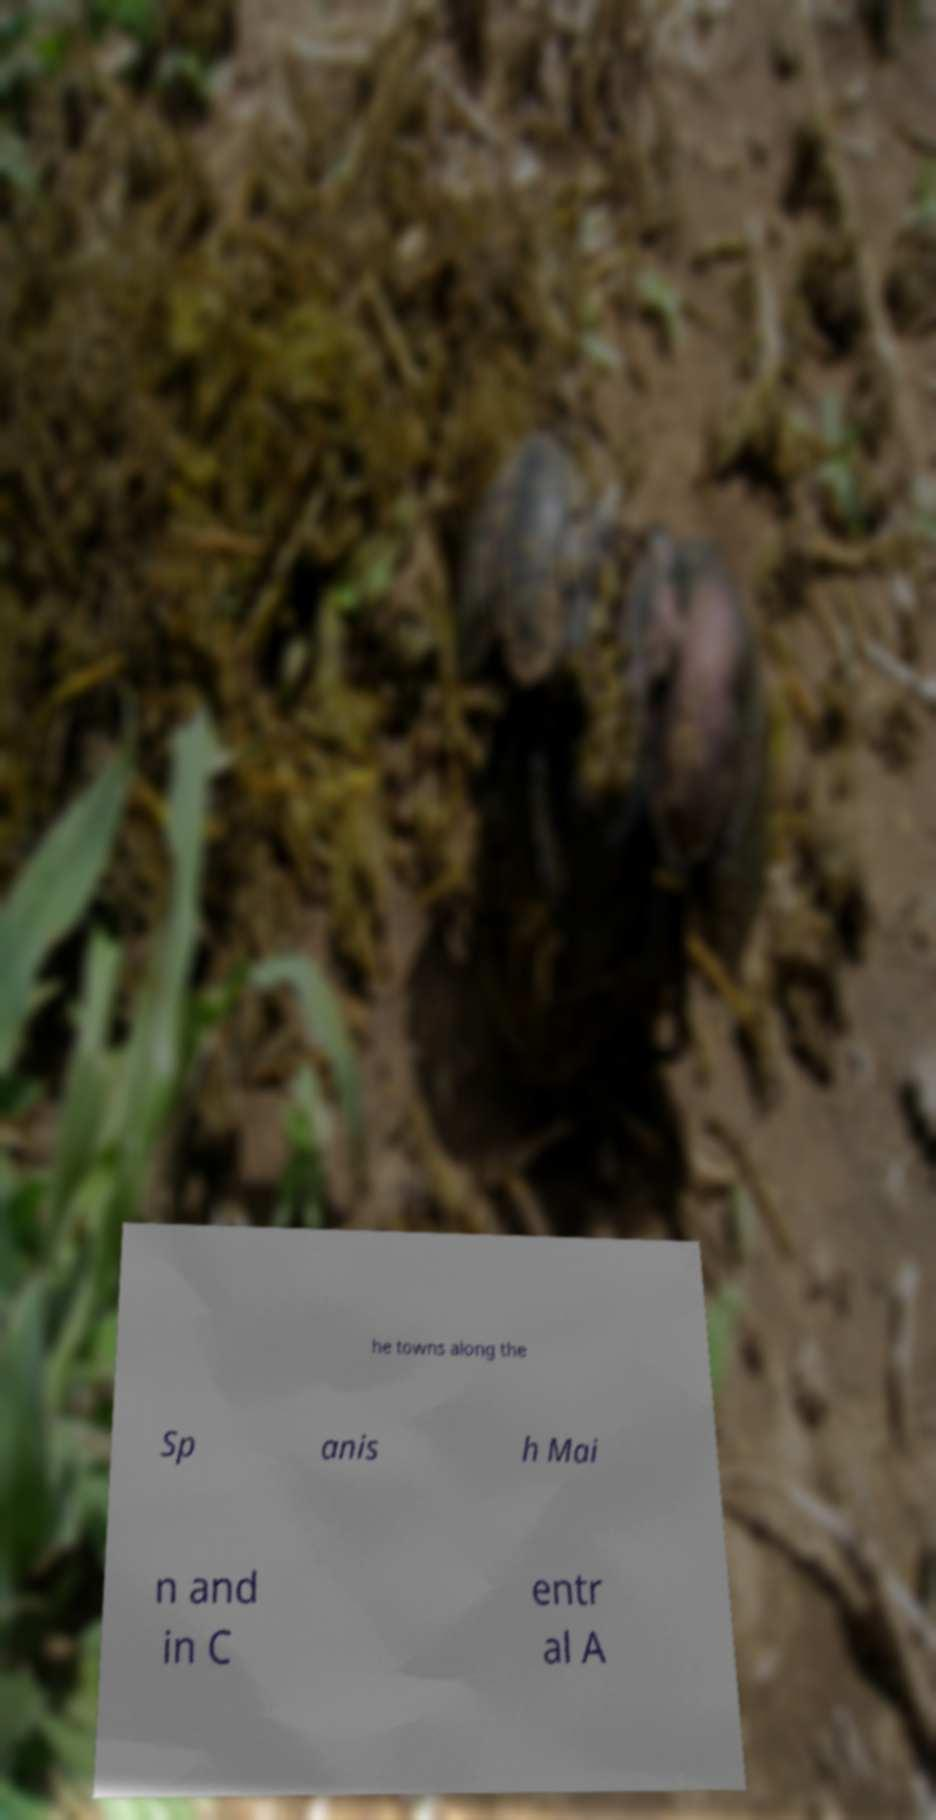Could you extract and type out the text from this image? he towns along the Sp anis h Mai n and in C entr al A 